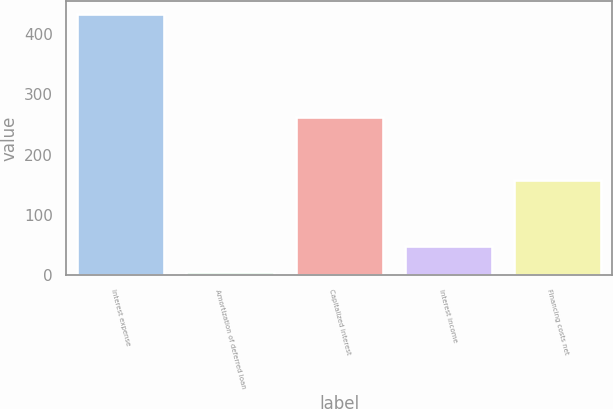Convert chart. <chart><loc_0><loc_0><loc_500><loc_500><bar_chart><fcel>Interest expense<fcel>Amortization of deferred loan<fcel>Capitalized interest<fcel>Interest income<fcel>Financing costs net<nl><fcel>433<fcel>5<fcel>263<fcel>47.8<fcel>158<nl></chart> 